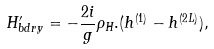Convert formula to latex. <formula><loc_0><loc_0><loc_500><loc_500>H _ { b d r y } ^ { \prime } = - \frac { 2 i } { g } \rho _ { H } . ( h ^ { ( 1 ) } - h ^ { ( 2 L ) } ) ,</formula> 